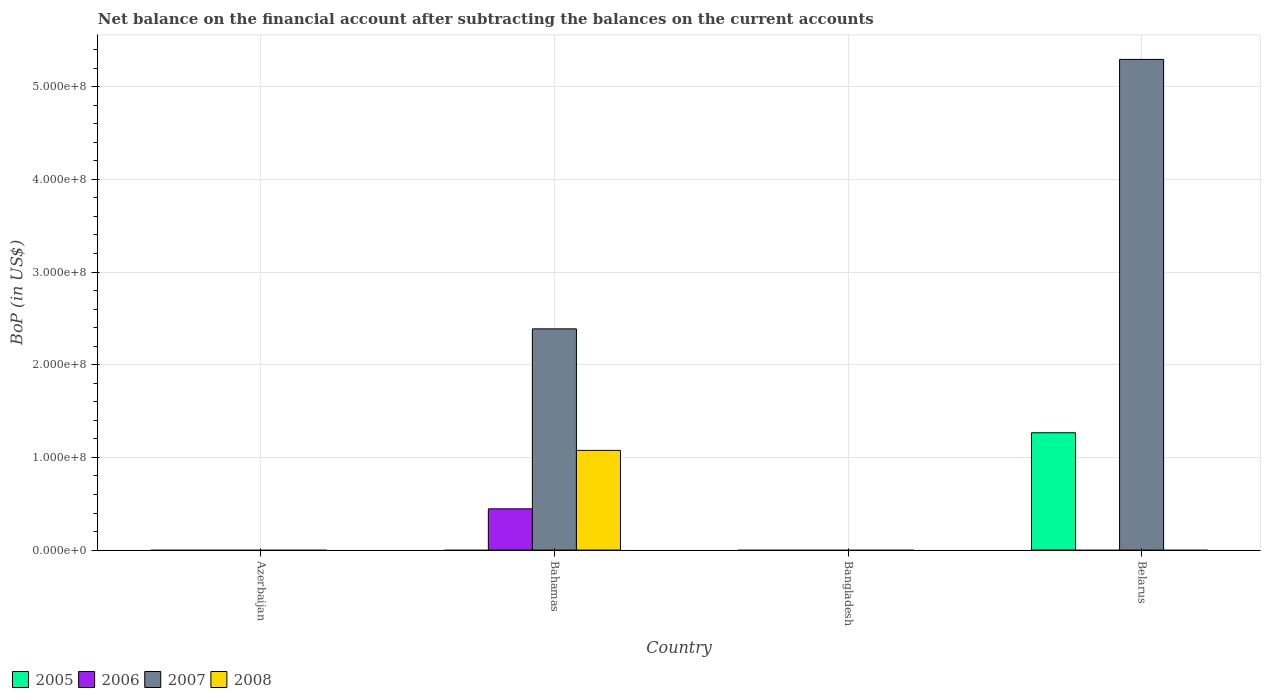How many different coloured bars are there?
Provide a short and direct response. 4. Are the number of bars on each tick of the X-axis equal?
Give a very brief answer. No. How many bars are there on the 4th tick from the left?
Your answer should be compact. 2. What is the label of the 1st group of bars from the left?
Keep it short and to the point. Azerbaijan. In how many cases, is the number of bars for a given country not equal to the number of legend labels?
Provide a succinct answer. 4. Across all countries, what is the maximum Balance of Payments in 2005?
Ensure brevity in your answer.  1.27e+08. Across all countries, what is the minimum Balance of Payments in 2007?
Keep it short and to the point. 0. In which country was the Balance of Payments in 2006 maximum?
Provide a succinct answer. Bahamas. What is the total Balance of Payments in 2007 in the graph?
Offer a terse response. 7.68e+08. What is the difference between the Balance of Payments in 2007 in Bahamas and that in Belarus?
Ensure brevity in your answer.  -2.91e+08. What is the difference between the Balance of Payments in 2005 in Bahamas and the Balance of Payments in 2008 in Belarus?
Your response must be concise. 0. What is the average Balance of Payments in 2008 per country?
Your response must be concise. 2.69e+07. What is the ratio of the Balance of Payments in 2007 in Bahamas to that in Belarus?
Your answer should be compact. 0.45. What is the difference between the highest and the lowest Balance of Payments in 2007?
Offer a terse response. 5.29e+08. In how many countries, is the Balance of Payments in 2005 greater than the average Balance of Payments in 2005 taken over all countries?
Offer a terse response. 1. Is it the case that in every country, the sum of the Balance of Payments in 2005 and Balance of Payments in 2008 is greater than the sum of Balance of Payments in 2007 and Balance of Payments in 2006?
Your answer should be compact. No. How many bars are there?
Offer a terse response. 5. What is the difference between two consecutive major ticks on the Y-axis?
Provide a succinct answer. 1.00e+08. Are the values on the major ticks of Y-axis written in scientific E-notation?
Your answer should be very brief. Yes. Does the graph contain any zero values?
Offer a very short reply. Yes. How many legend labels are there?
Offer a very short reply. 4. How are the legend labels stacked?
Offer a terse response. Horizontal. What is the title of the graph?
Offer a terse response. Net balance on the financial account after subtracting the balances on the current accounts. What is the label or title of the X-axis?
Your response must be concise. Country. What is the label or title of the Y-axis?
Give a very brief answer. BoP (in US$). What is the BoP (in US$) in 2005 in Azerbaijan?
Your response must be concise. 0. What is the BoP (in US$) of 2006 in Bahamas?
Offer a terse response. 4.45e+07. What is the BoP (in US$) in 2007 in Bahamas?
Your answer should be very brief. 2.39e+08. What is the BoP (in US$) of 2008 in Bahamas?
Keep it short and to the point. 1.08e+08. What is the BoP (in US$) in 2005 in Bangladesh?
Your answer should be very brief. 0. What is the BoP (in US$) of 2005 in Belarus?
Your response must be concise. 1.27e+08. What is the BoP (in US$) in 2006 in Belarus?
Provide a succinct answer. 0. What is the BoP (in US$) of 2007 in Belarus?
Provide a succinct answer. 5.29e+08. Across all countries, what is the maximum BoP (in US$) in 2005?
Give a very brief answer. 1.27e+08. Across all countries, what is the maximum BoP (in US$) of 2006?
Ensure brevity in your answer.  4.45e+07. Across all countries, what is the maximum BoP (in US$) in 2007?
Provide a short and direct response. 5.29e+08. Across all countries, what is the maximum BoP (in US$) of 2008?
Offer a very short reply. 1.08e+08. What is the total BoP (in US$) in 2005 in the graph?
Make the answer very short. 1.27e+08. What is the total BoP (in US$) in 2006 in the graph?
Your answer should be very brief. 4.45e+07. What is the total BoP (in US$) in 2007 in the graph?
Ensure brevity in your answer.  7.68e+08. What is the total BoP (in US$) in 2008 in the graph?
Give a very brief answer. 1.08e+08. What is the difference between the BoP (in US$) of 2007 in Bahamas and that in Belarus?
Give a very brief answer. -2.91e+08. What is the difference between the BoP (in US$) in 2006 in Bahamas and the BoP (in US$) in 2007 in Belarus?
Provide a short and direct response. -4.85e+08. What is the average BoP (in US$) of 2005 per country?
Offer a very short reply. 3.16e+07. What is the average BoP (in US$) of 2006 per country?
Your response must be concise. 1.11e+07. What is the average BoP (in US$) in 2007 per country?
Give a very brief answer. 1.92e+08. What is the average BoP (in US$) in 2008 per country?
Your answer should be very brief. 2.69e+07. What is the difference between the BoP (in US$) in 2006 and BoP (in US$) in 2007 in Bahamas?
Give a very brief answer. -1.94e+08. What is the difference between the BoP (in US$) of 2006 and BoP (in US$) of 2008 in Bahamas?
Ensure brevity in your answer.  -6.31e+07. What is the difference between the BoP (in US$) in 2007 and BoP (in US$) in 2008 in Bahamas?
Offer a terse response. 1.31e+08. What is the difference between the BoP (in US$) in 2005 and BoP (in US$) in 2007 in Belarus?
Offer a very short reply. -4.03e+08. What is the ratio of the BoP (in US$) of 2007 in Bahamas to that in Belarus?
Make the answer very short. 0.45. What is the difference between the highest and the lowest BoP (in US$) in 2005?
Your answer should be very brief. 1.27e+08. What is the difference between the highest and the lowest BoP (in US$) in 2006?
Offer a very short reply. 4.45e+07. What is the difference between the highest and the lowest BoP (in US$) in 2007?
Your answer should be very brief. 5.29e+08. What is the difference between the highest and the lowest BoP (in US$) in 2008?
Offer a very short reply. 1.08e+08. 